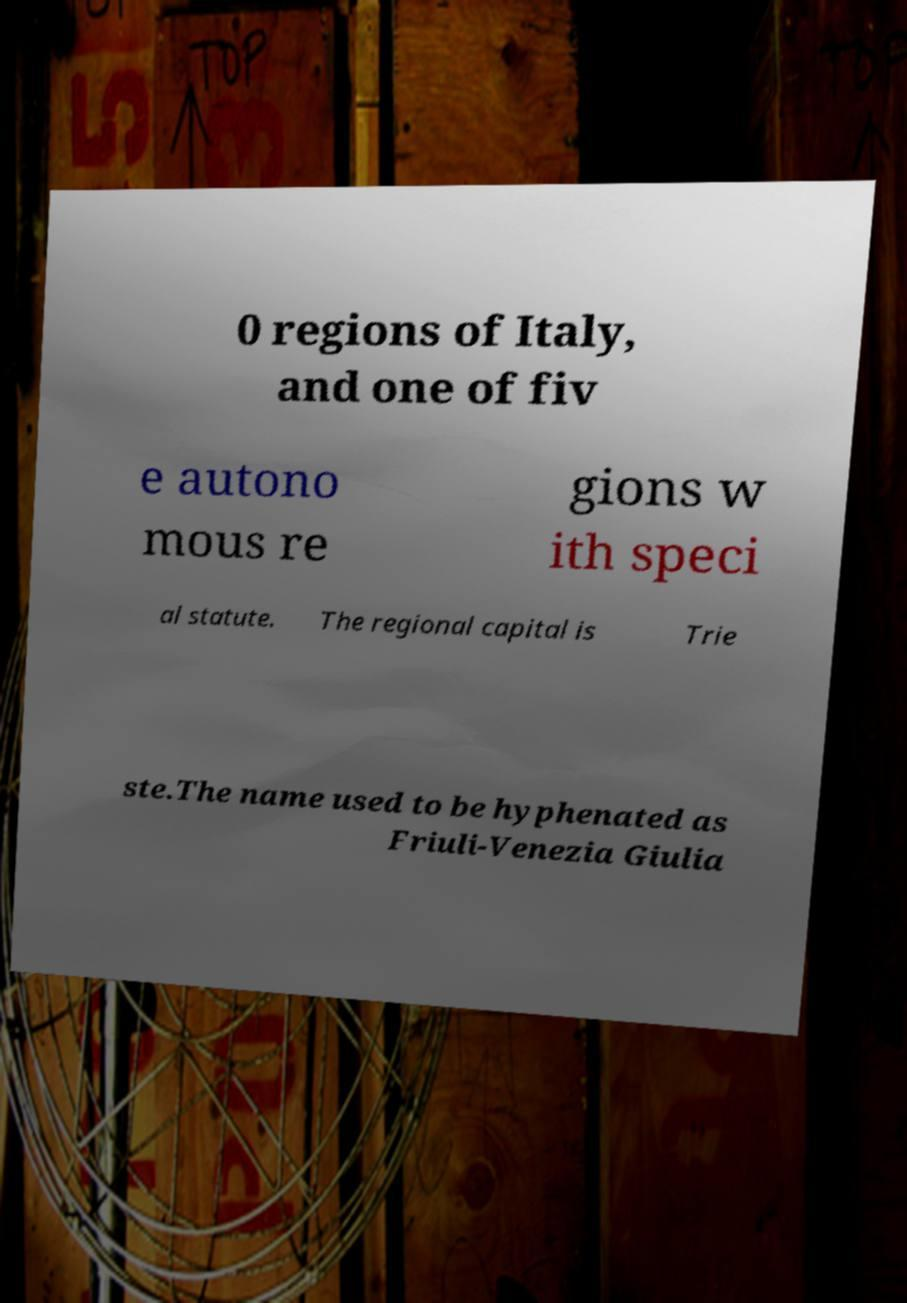I need the written content from this picture converted into text. Can you do that? 0 regions of Italy, and one of fiv e autono mous re gions w ith speci al statute. The regional capital is Trie ste.The name used to be hyphenated as Friuli-Venezia Giulia 